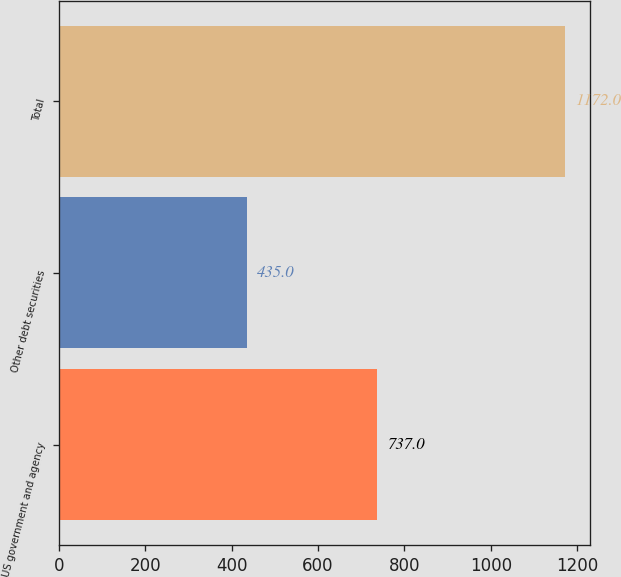Convert chart. <chart><loc_0><loc_0><loc_500><loc_500><bar_chart><fcel>US government and agency<fcel>Other debt securities<fcel>Total<nl><fcel>737<fcel>435<fcel>1172<nl></chart> 